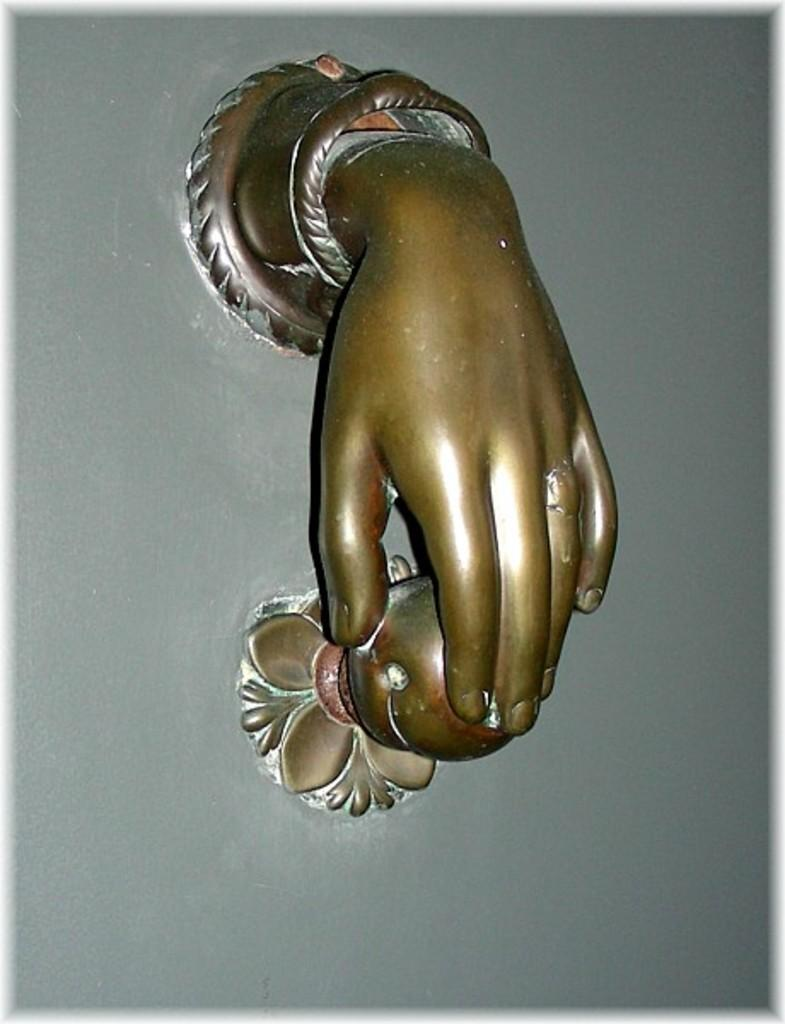What is the main subject in the image? There is a statue in the image. Can you hear the statue sneezing in the image? There is no sound or indication of a sneeze in the image, as it is a static representation of a statue. 